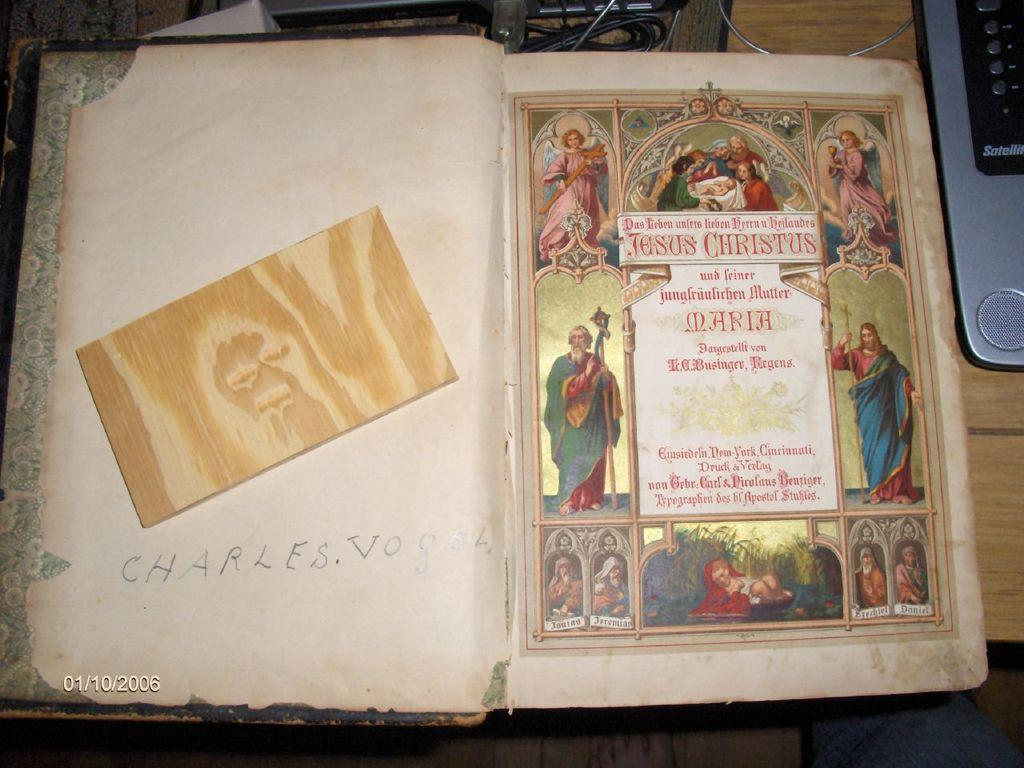<image>
Provide a brief description of the given image. An open book with the name Charles printed inside it. 